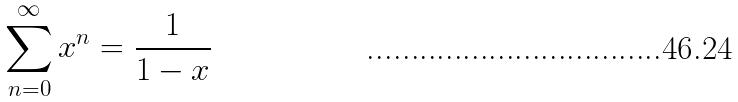<formula> <loc_0><loc_0><loc_500><loc_500>\sum _ { n = 0 } ^ { \infty } x ^ { n } = \frac { 1 } { 1 - x }</formula> 